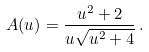Convert formula to latex. <formula><loc_0><loc_0><loc_500><loc_500>A ( u ) = \frac { u ^ { 2 } + 2 } { u \sqrt { u ^ { 2 } + 4 } } \, .</formula> 